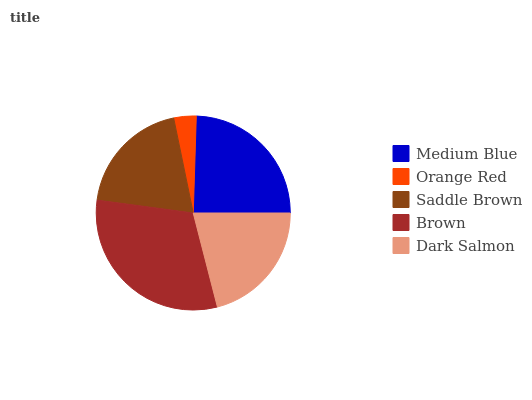Is Orange Red the minimum?
Answer yes or no. Yes. Is Brown the maximum?
Answer yes or no. Yes. Is Saddle Brown the minimum?
Answer yes or no. No. Is Saddle Brown the maximum?
Answer yes or no. No. Is Saddle Brown greater than Orange Red?
Answer yes or no. Yes. Is Orange Red less than Saddle Brown?
Answer yes or no. Yes. Is Orange Red greater than Saddle Brown?
Answer yes or no. No. Is Saddle Brown less than Orange Red?
Answer yes or no. No. Is Dark Salmon the high median?
Answer yes or no. Yes. Is Dark Salmon the low median?
Answer yes or no. Yes. Is Orange Red the high median?
Answer yes or no. No. Is Orange Red the low median?
Answer yes or no. No. 